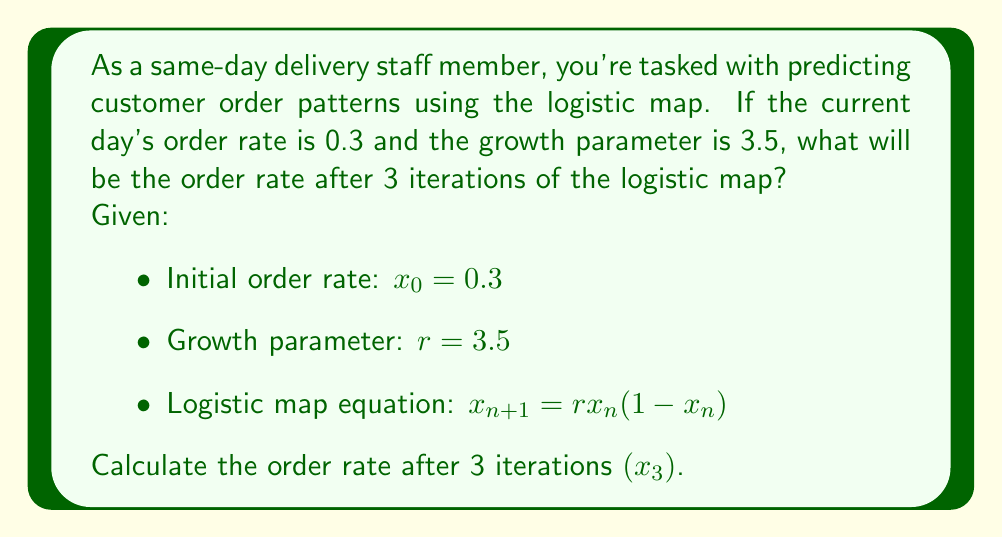Provide a solution to this math problem. To solve this problem, we need to apply the logistic map equation iteratively for 3 steps:

Step 1: Calculate $x_1$
$$x_1 = r \cdot x_0 \cdot (1-x_0)$$
$$x_1 = 3.5 \cdot 0.3 \cdot (1-0.3)$$
$$x_1 = 3.5 \cdot 0.3 \cdot 0.7 = 0.735$$

Step 2: Calculate $x_2$
$$x_2 = r \cdot x_1 \cdot (1-x_1)$$
$$x_2 = 3.5 \cdot 0.735 \cdot (1-0.735)$$
$$x_2 = 3.5 \cdot 0.735 \cdot 0.265 = 0.68134375$$

Step 3: Calculate $x_3$
$$x_3 = r \cdot x_2 \cdot (1-x_2)$$
$$x_3 = 3.5 \cdot 0.68134375 \cdot (1-0.68134375)$$
$$x_3 = 3.5 \cdot 0.68134375 \cdot 0.31865625 = 0.7592311448$$

Therefore, after 3 iterations, the order rate will be approximately 0.7592.
Answer: 0.7592 